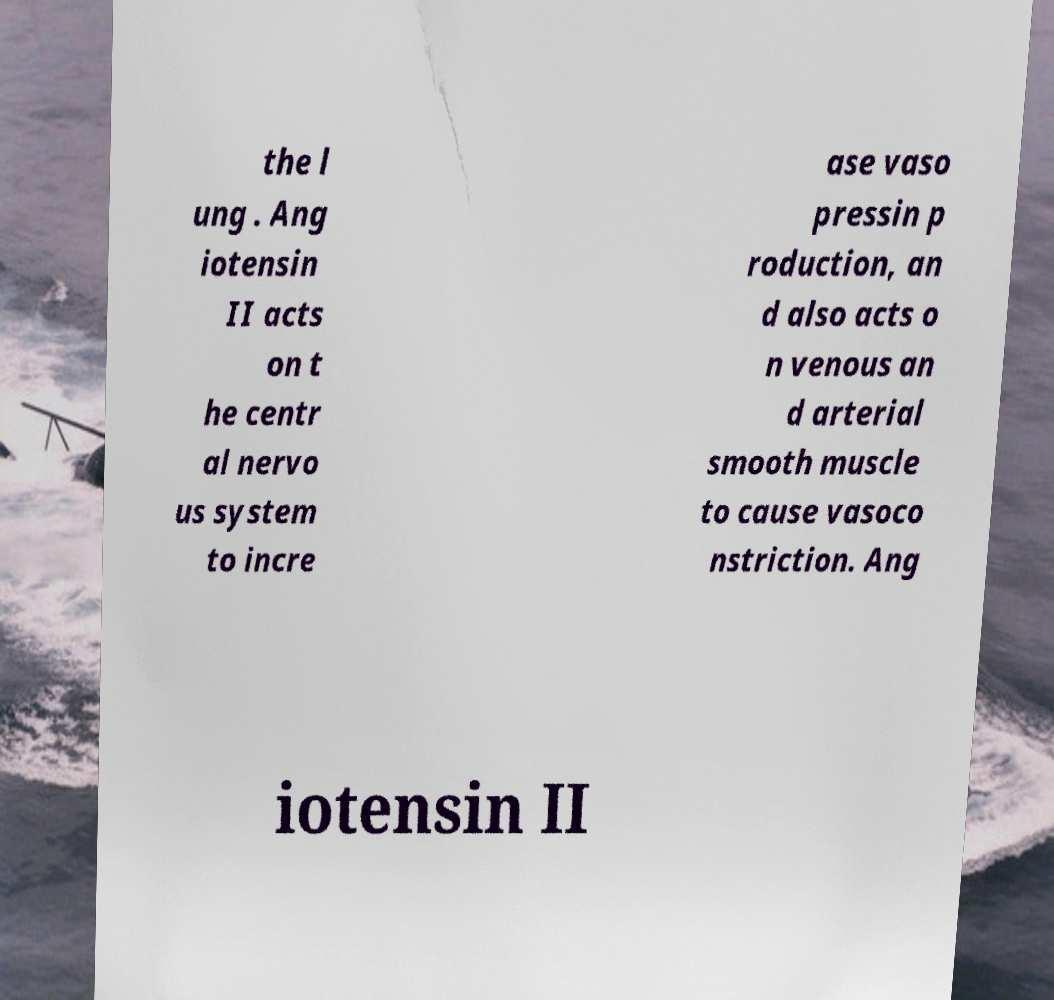Please read and relay the text visible in this image. What does it say? the l ung . Ang iotensin II acts on t he centr al nervo us system to incre ase vaso pressin p roduction, an d also acts o n venous an d arterial smooth muscle to cause vasoco nstriction. Ang iotensin II 